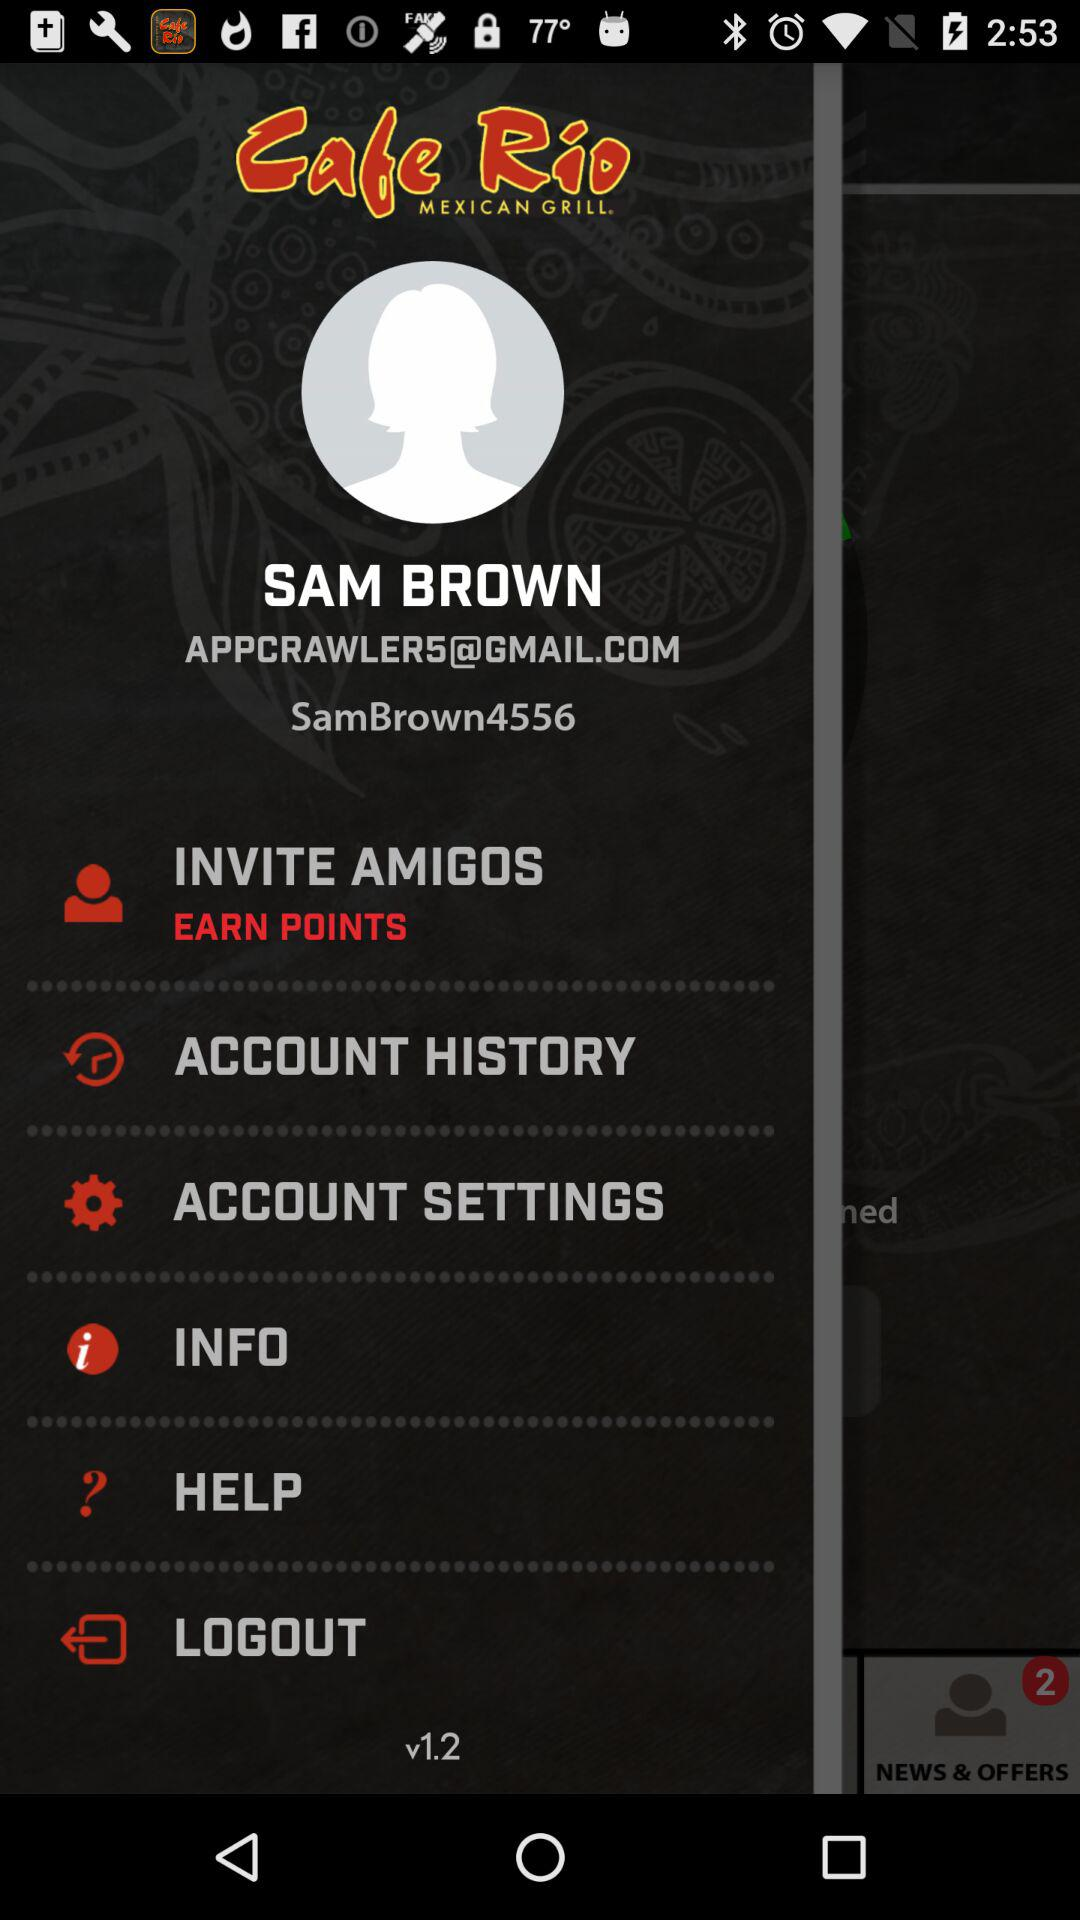What is the name of the user? The name of the user is Sam Brown. 